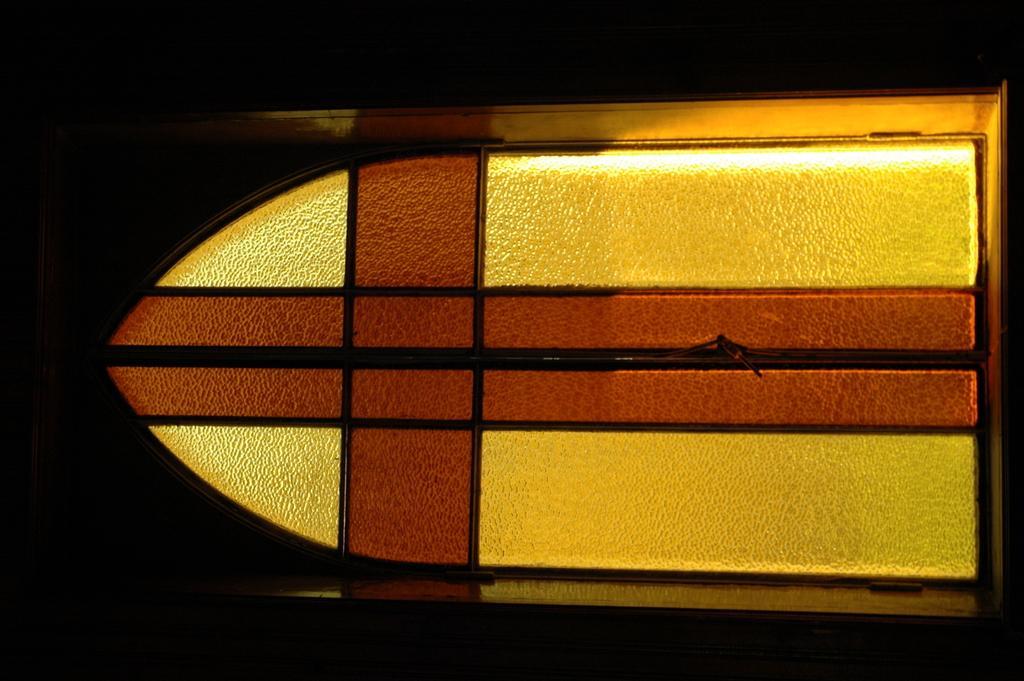Can you describe this image briefly? In the middle of the picture, we see a door in yellow and brown color. On the left side, it is black in color. In the background, it is black in color. This picture is clicked in the dark. 